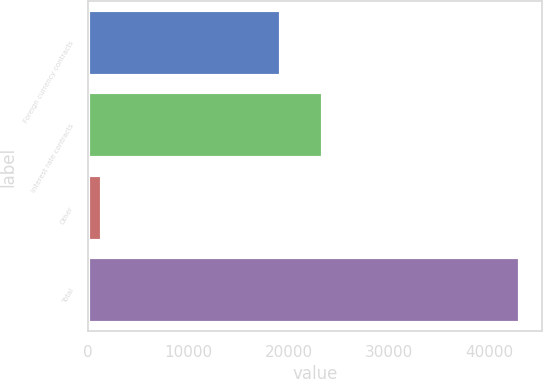Convert chart to OTSL. <chart><loc_0><loc_0><loc_500><loc_500><bar_chart><fcel>Foreign currency contracts<fcel>Interest rate contracts<fcel>Other<fcel>Total<nl><fcel>19223<fcel>23390<fcel>1356<fcel>43026<nl></chart> 